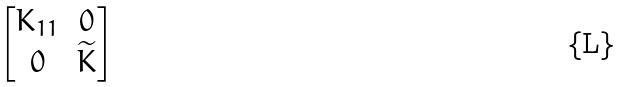<formula> <loc_0><loc_0><loc_500><loc_500>\begin{bmatrix} K _ { 1 1 } & 0 \\ 0 & \widetilde { K } \end{bmatrix}</formula> 